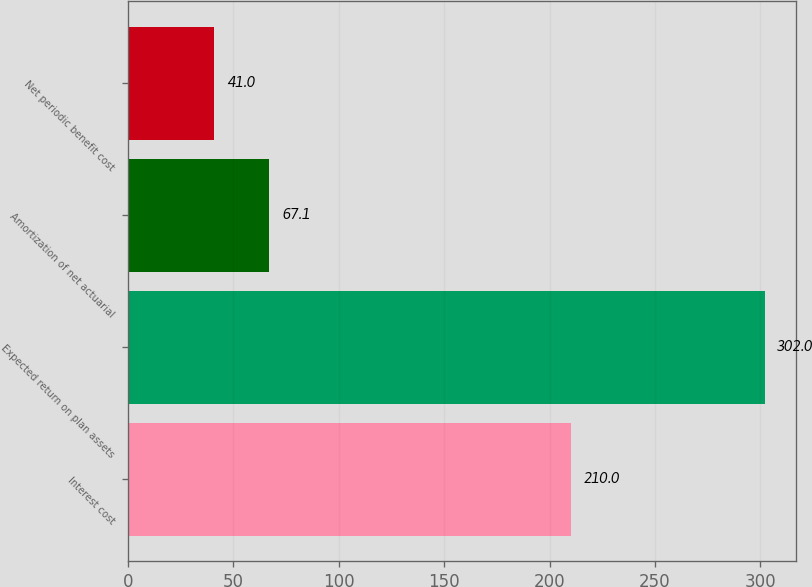<chart> <loc_0><loc_0><loc_500><loc_500><bar_chart><fcel>Interest cost<fcel>Expected return on plan assets<fcel>Amortization of net actuarial<fcel>Net periodic benefit cost<nl><fcel>210<fcel>302<fcel>67.1<fcel>41<nl></chart> 